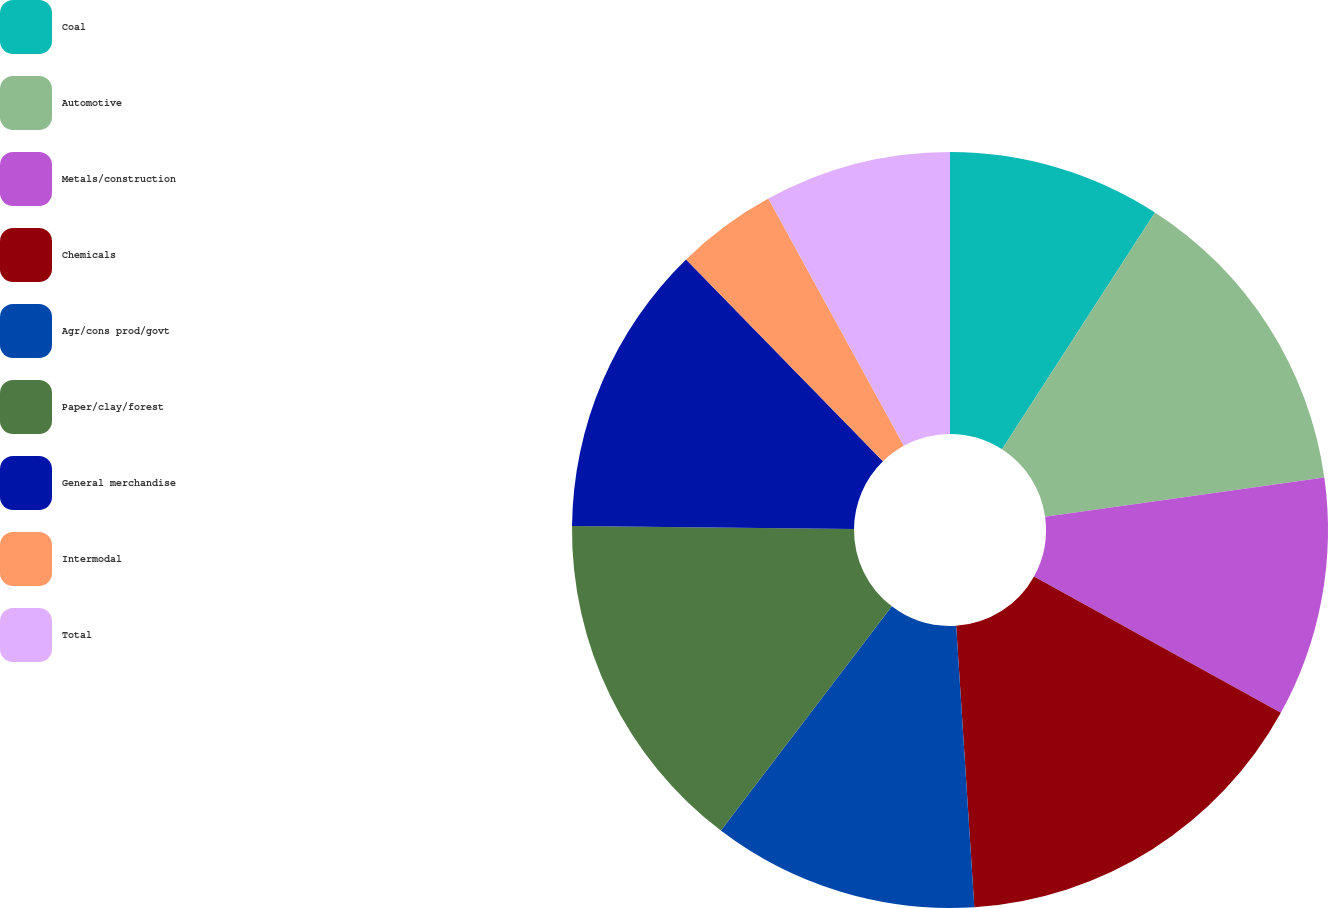Convert chart. <chart><loc_0><loc_0><loc_500><loc_500><pie_chart><fcel>Coal<fcel>Automotive<fcel>Metals/construction<fcel>Chemicals<fcel>Agr/cons prod/govt<fcel>Paper/clay/forest<fcel>General merchandise<fcel>Intermodal<fcel>Total<nl><fcel>9.12%<fcel>13.66%<fcel>10.25%<fcel>15.94%<fcel>11.39%<fcel>14.8%<fcel>12.53%<fcel>4.32%<fcel>7.98%<nl></chart> 